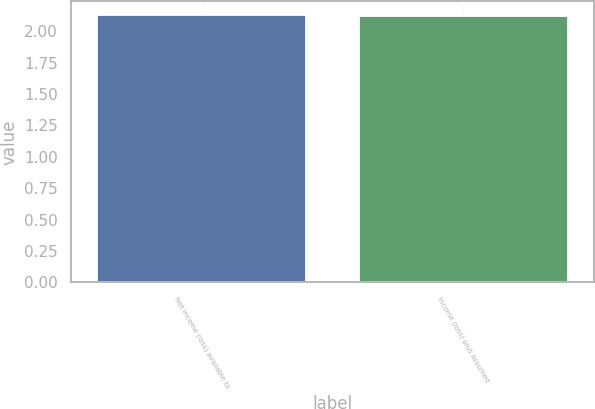Convert chart to OTSL. <chart><loc_0><loc_0><loc_500><loc_500><bar_chart><fcel>Net income (loss) available to<fcel>Income (loss) plus assumed<nl><fcel>2.13<fcel>2.12<nl></chart> 